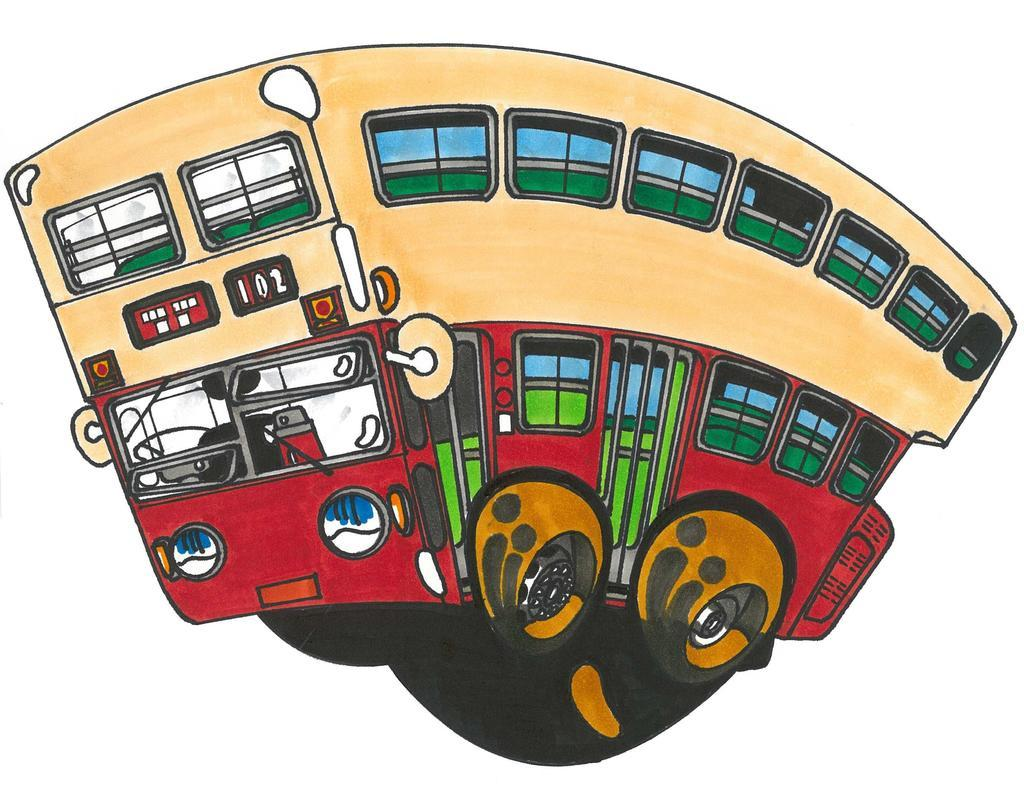What is the main subject of the painting in the image? There is a painting of a bus in the image. What color is the background of the painting? The background of the image is white. What type of lock is used to secure the bus in the image? There is no lock present in the image, as it is a painting of a bus. What color is the hair of the bus driver in the image? There is no bus driver present in the image, as it is a painting of a bus. 